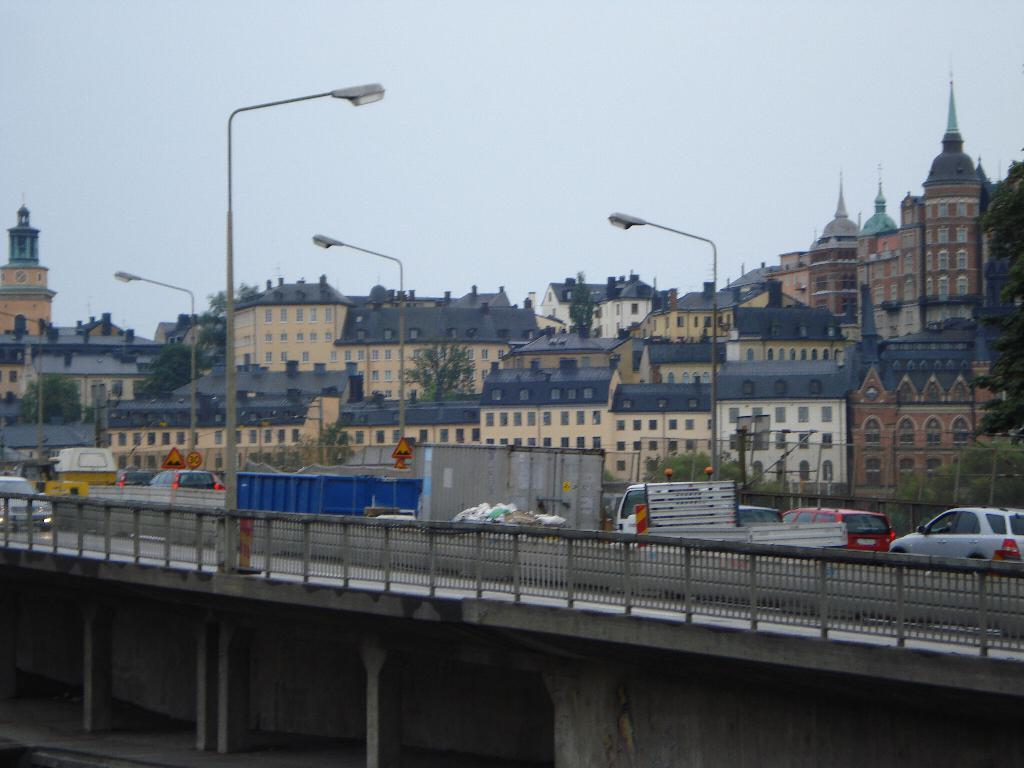What type of structure can be seen in the image? There is a bridge in the image. What other object can be seen in the image? There is a fence in the image. What is moving in the image? Vehicles are present in the image. What can be seen illuminating the area in the image? There are lights in the image. What is attached to the poles in the image? Boards are visible on poles. What can be seen in the distance in the image? There are buildings, trees, and the sky visible in the background of the image. Can you tell me how many times the scarecrow sneezes in the image? There is no scarecrow present in the image, and therefore no sneezing can be observed. 